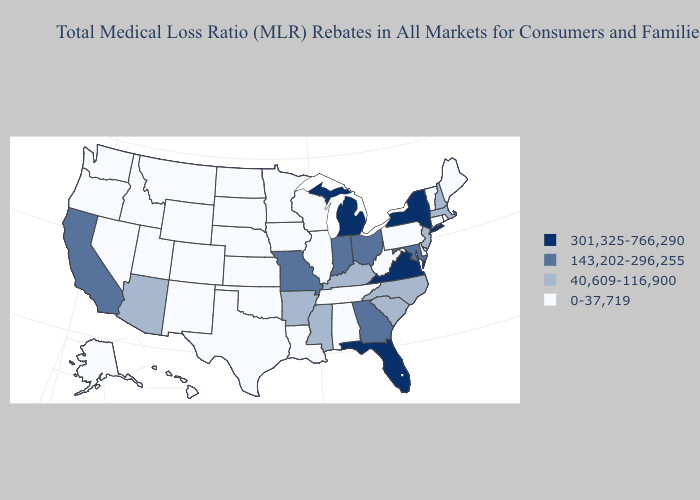What is the value of Ohio?
Write a very short answer. 143,202-296,255. Does Texas have the highest value in the USA?
Write a very short answer. No. Name the states that have a value in the range 301,325-766,290?
Write a very short answer. Florida, Michigan, New York, Virginia. What is the value of Oklahoma?
Keep it brief. 0-37,719. What is the lowest value in the USA?
Write a very short answer. 0-37,719. Does Mississippi have the lowest value in the USA?
Answer briefly. No. Does Georgia have a lower value than Michigan?
Answer briefly. Yes. Does Missouri have the lowest value in the MidWest?
Give a very brief answer. No. Name the states that have a value in the range 301,325-766,290?
Be succinct. Florida, Michigan, New York, Virginia. Which states hav the highest value in the MidWest?
Short answer required. Michigan. Among the states that border Rhode Island , which have the lowest value?
Concise answer only. Connecticut. Name the states that have a value in the range 0-37,719?
Give a very brief answer. Alabama, Alaska, Colorado, Connecticut, Delaware, Hawaii, Idaho, Illinois, Iowa, Kansas, Louisiana, Maine, Minnesota, Montana, Nebraska, Nevada, New Mexico, North Dakota, Oklahoma, Oregon, Pennsylvania, Rhode Island, South Dakota, Tennessee, Texas, Utah, Vermont, Washington, West Virginia, Wisconsin, Wyoming. What is the value of Arkansas?
Quick response, please. 40,609-116,900. Name the states that have a value in the range 143,202-296,255?
Short answer required. California, Georgia, Indiana, Maryland, Missouri, Ohio. 